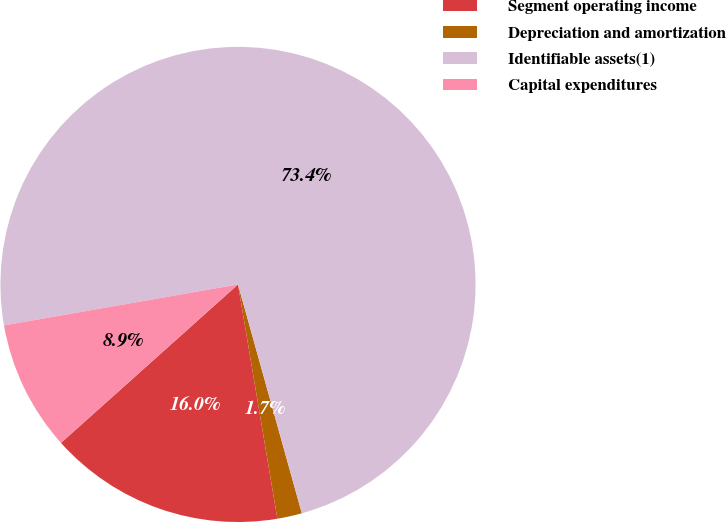Convert chart. <chart><loc_0><loc_0><loc_500><loc_500><pie_chart><fcel>Segment operating income<fcel>Depreciation and amortization<fcel>Identifiable assets(1)<fcel>Capital expenditures<nl><fcel>16.03%<fcel>1.68%<fcel>73.42%<fcel>8.86%<nl></chart> 